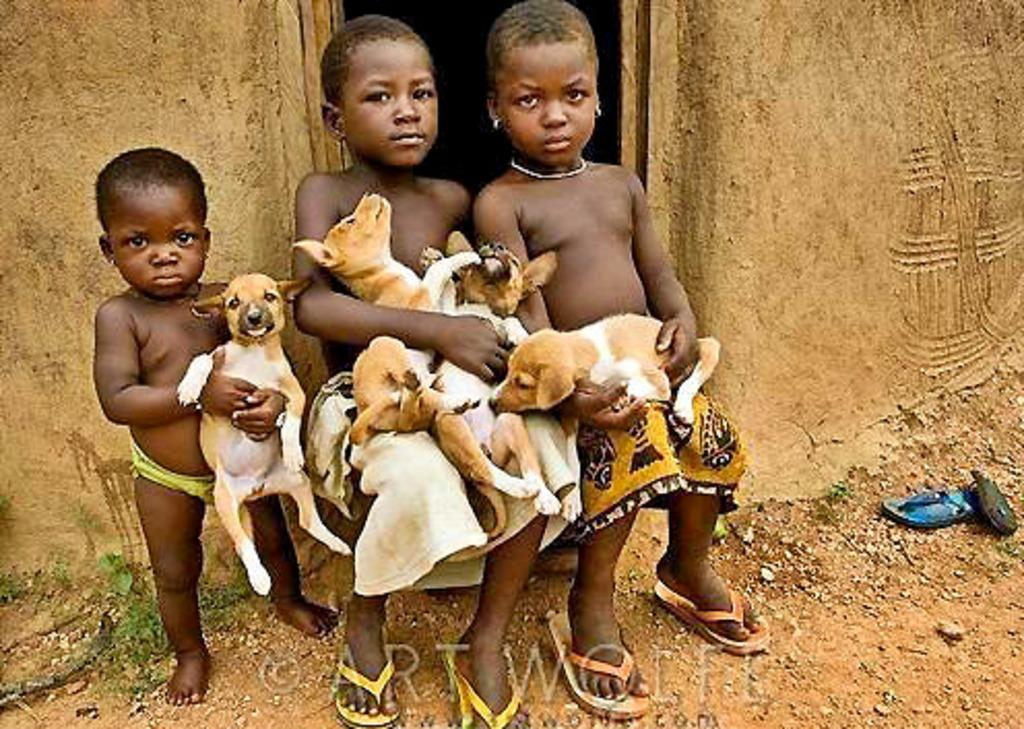How many people are sitting on the steps in the image? There are three persons sitting on the steps in the image. What are the persons holding in their hands? The persons are holding dogs in their hands. What can be seen in the background of the image? There is a wall, a door, and a slipper in the background. How many kittens are sleeping on the beds in the image? There are no beds or kittens present in the image. What type of spoon is being used by the persons in the image? There is no spoon visible in the image; the persons are holding dogs. 